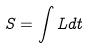<formula> <loc_0><loc_0><loc_500><loc_500>S = \int L d t</formula> 